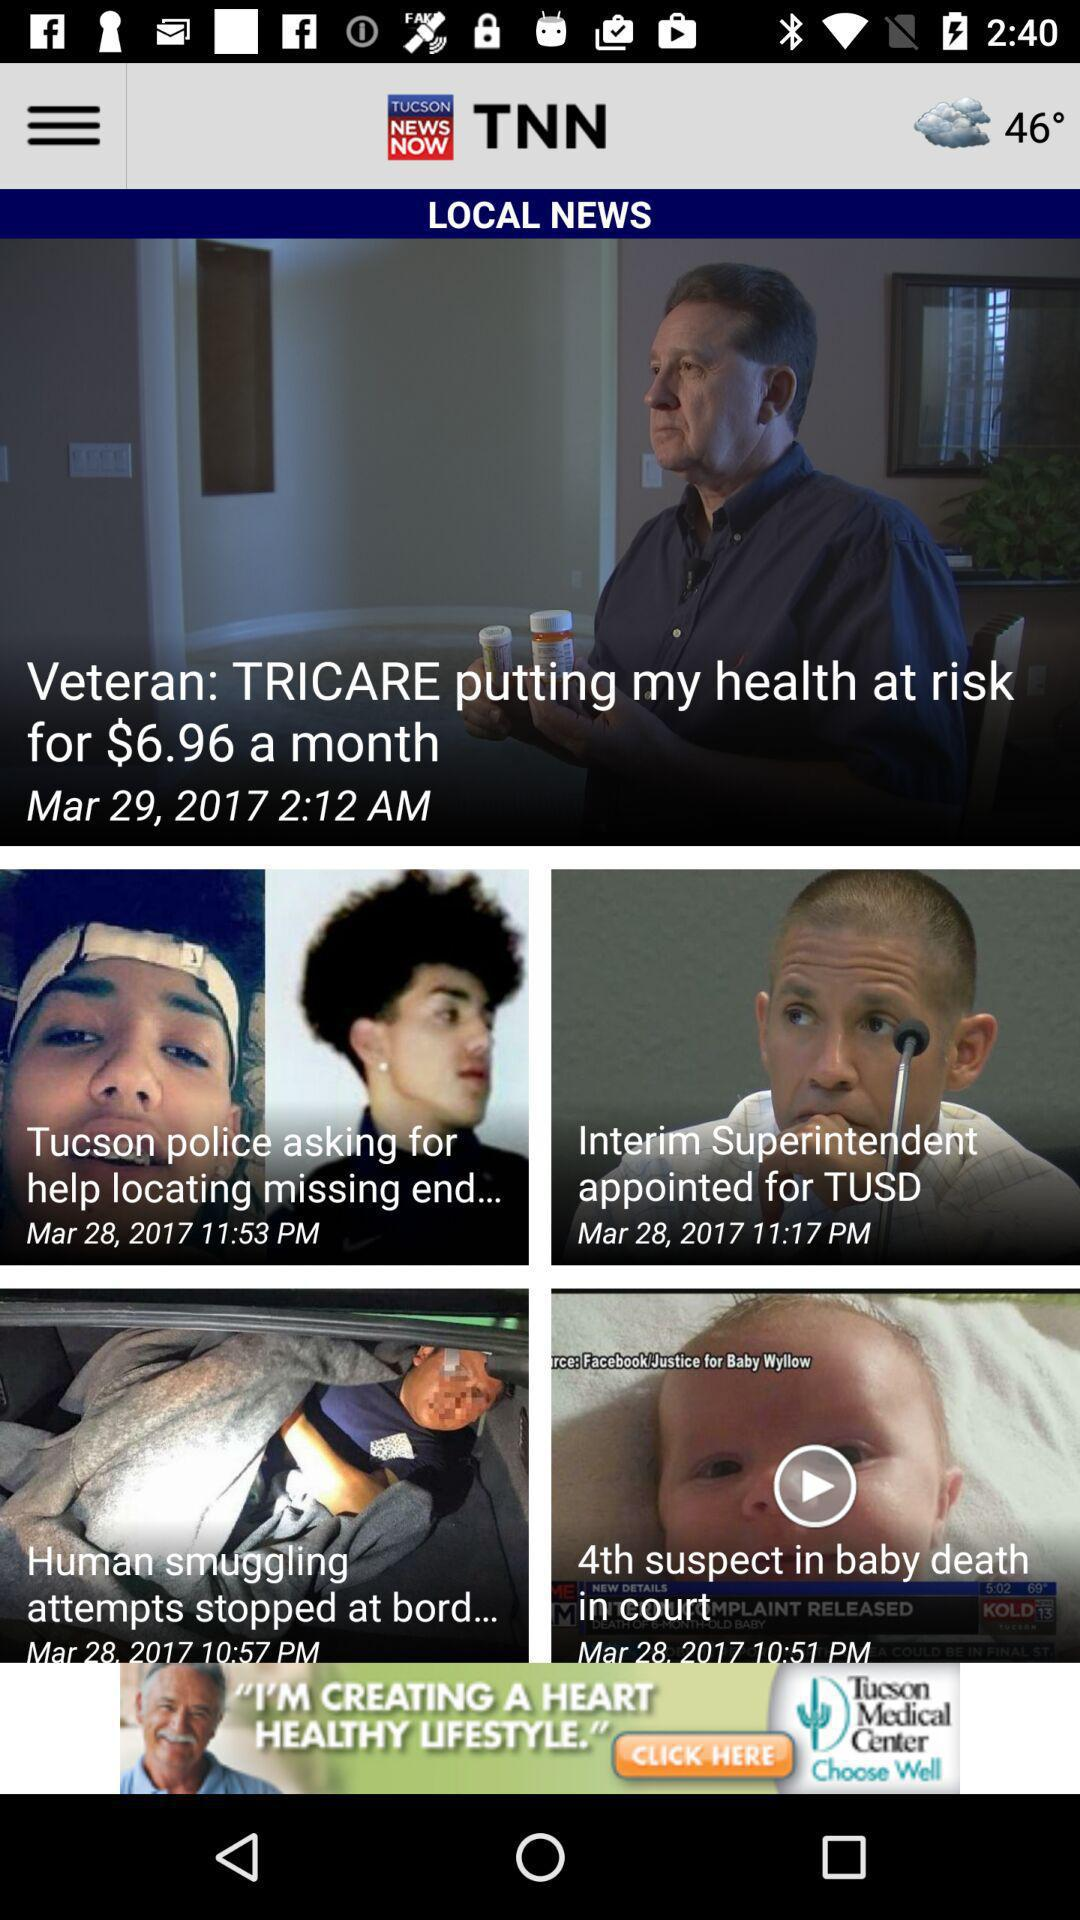When was the news about the veteran published? The news was published on March 29, 2017 at 2:12 AM. 